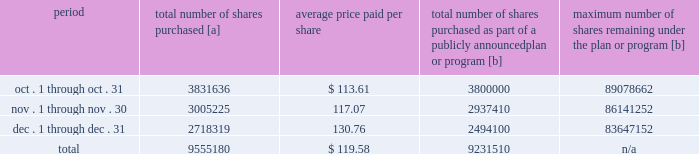Five-year performance comparison 2013 the following graph provides an indicator of cumulative total shareholder returns for the corporation as compared to the peer group index ( described above ) , the dj trans , and the s&p 500 .
The graph assumes that $ 100 was invested in the common stock of union pacific corporation and each index on december 31 , 2012 and that all dividends were reinvested .
The information below is historical in nature and is not necessarily indicative of future performance .
Purchases of equity securities 2013 during 2017 , we repurchased 37122405 shares of our common stock at an average price of $ 110.50 .
The table presents common stock repurchases during each month for the fourth quarter of 2017 : period total number of shares purchased [a] average price paid per share total number of shares purchased as part of a publicly announced plan or program [b] maximum number of shares remaining under the plan or program [b] .
[a] total number of shares purchased during the quarter includes approximately 323670 shares delivered or attested to upc by employees to pay stock option exercise prices , satisfy excess tax withholding obligations for stock option exercises or vesting of retention units , and pay withholding obligations for vesting of retention shares .
[b] effective january 1 , 2017 , our board of directors authorized the repurchase of up to 120 million shares of our common stock by december 31 , 2020 .
These repurchases may be made on the open market or through other transactions .
Our management has sole discretion with respect to determining the timing and amount of these transactions. .
For the fourth quarter of 2017 what was the percent of the total number of shares attested to upc by employees to pay stock option exercise prices? 
Computations: (323670 / 9555180)
Answer: 0.03387. 